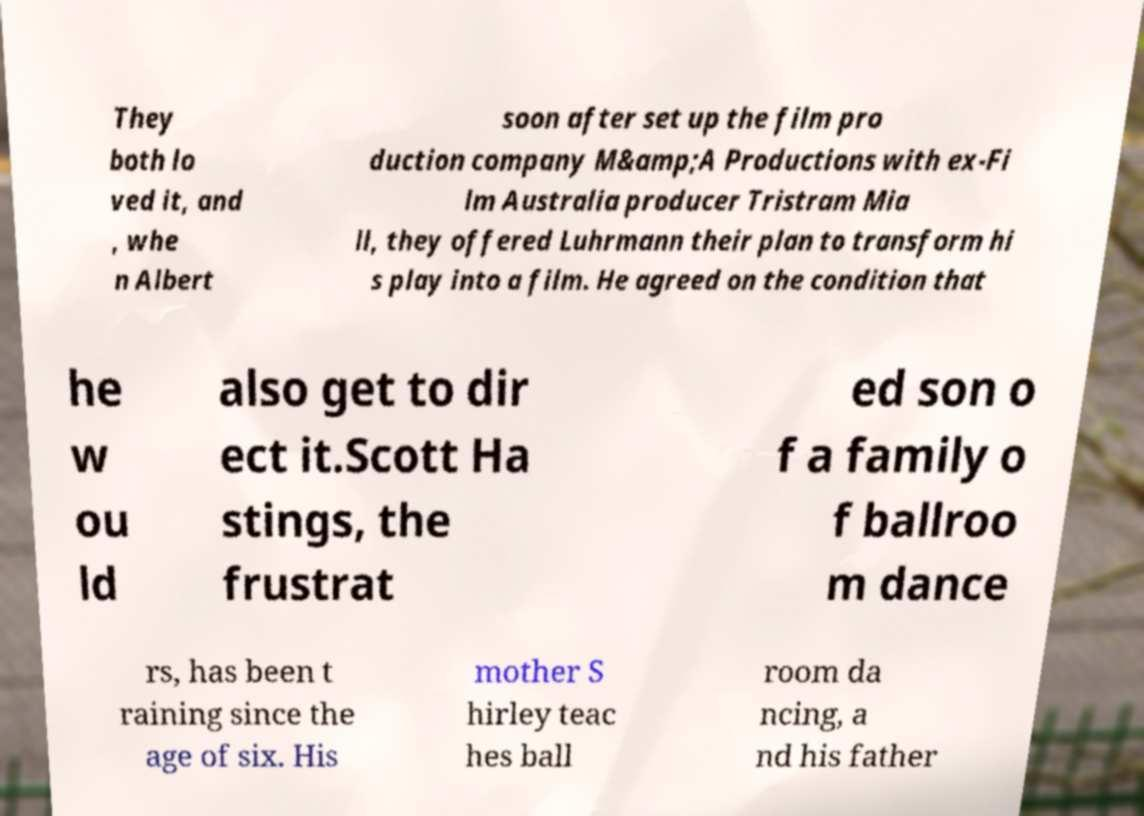Please identify and transcribe the text found in this image. They both lo ved it, and , whe n Albert soon after set up the film pro duction company M&amp;A Productions with ex-Fi lm Australia producer Tristram Mia ll, they offered Luhrmann their plan to transform hi s play into a film. He agreed on the condition that he w ou ld also get to dir ect it.Scott Ha stings, the frustrat ed son o f a family o f ballroo m dance rs, has been t raining since the age of six. His mother S hirley teac hes ball room da ncing, a nd his father 